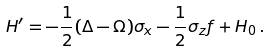Convert formula to latex. <formula><loc_0><loc_0><loc_500><loc_500>H ^ { \prime } = - \frac { 1 } { 2 } ( \Delta - \Omega ) \sigma _ { x } - \frac { 1 } { 2 } \sigma _ { z } f + H _ { 0 } \, .</formula> 